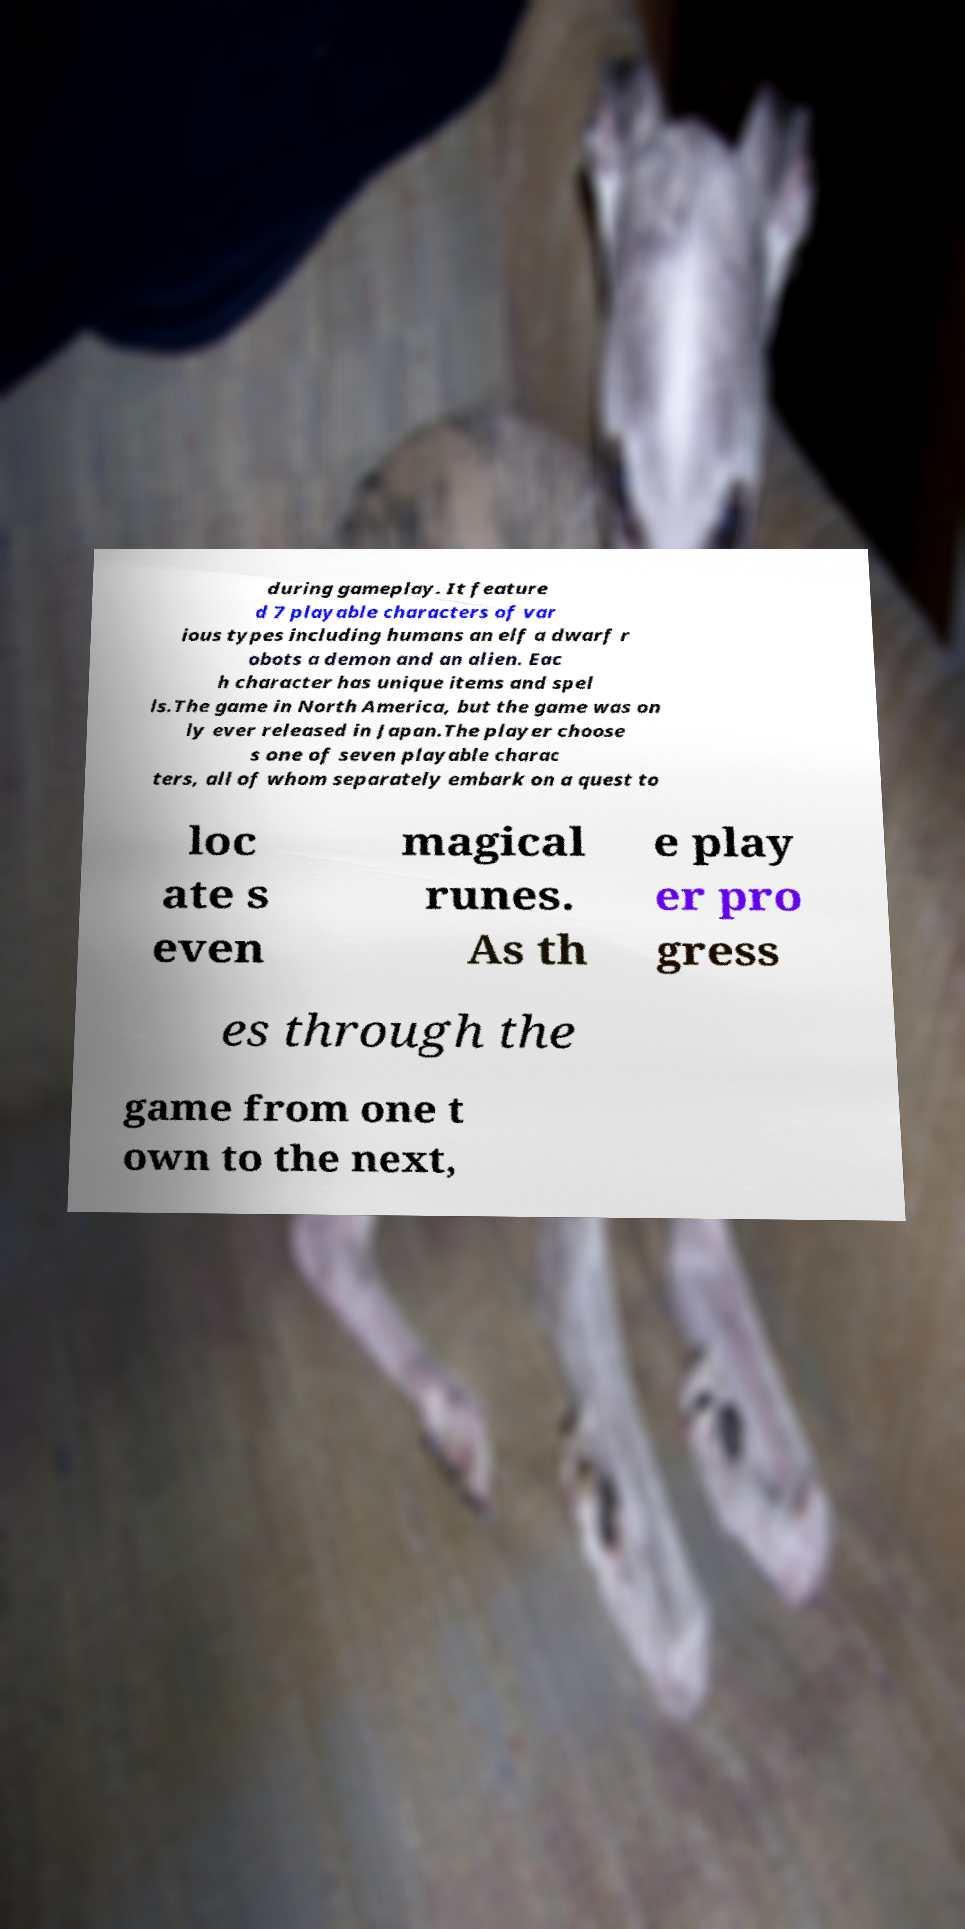Can you accurately transcribe the text from the provided image for me? during gameplay. It feature d 7 playable characters of var ious types including humans an elf a dwarf r obots a demon and an alien. Eac h character has unique items and spel ls.The game in North America, but the game was on ly ever released in Japan.The player choose s one of seven playable charac ters, all of whom separately embark on a quest to loc ate s even magical runes. As th e play er pro gress es through the game from one t own to the next, 